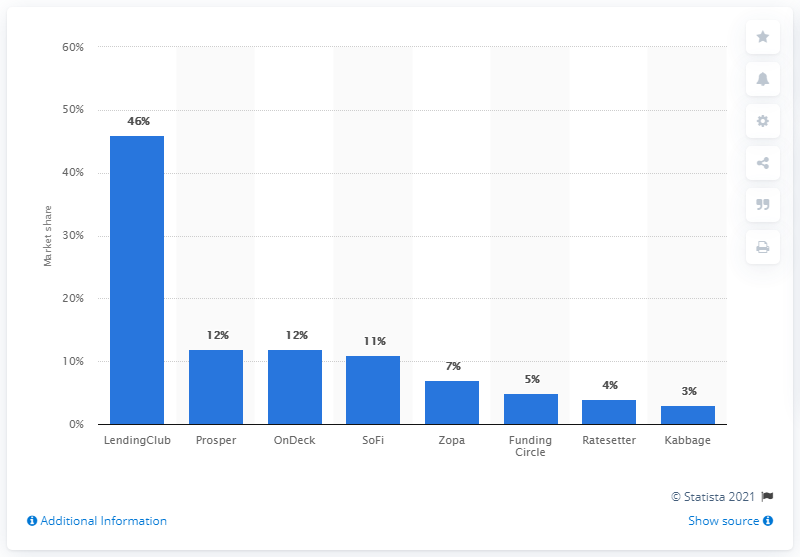List a handful of essential elements in this visual. Sofi had a global market share of around 11% in 2014. 